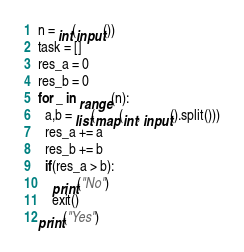Convert code to text. <code><loc_0><loc_0><loc_500><loc_500><_Python_>n = int(input())
task = []
res_a = 0
res_b = 0
for _ in range(n):
  a,b = list(map(int, input().split()))
  res_a += a
  res_b += b
  if(res_a > b):
    print("No")
    exit()
print("Yes")</code> 